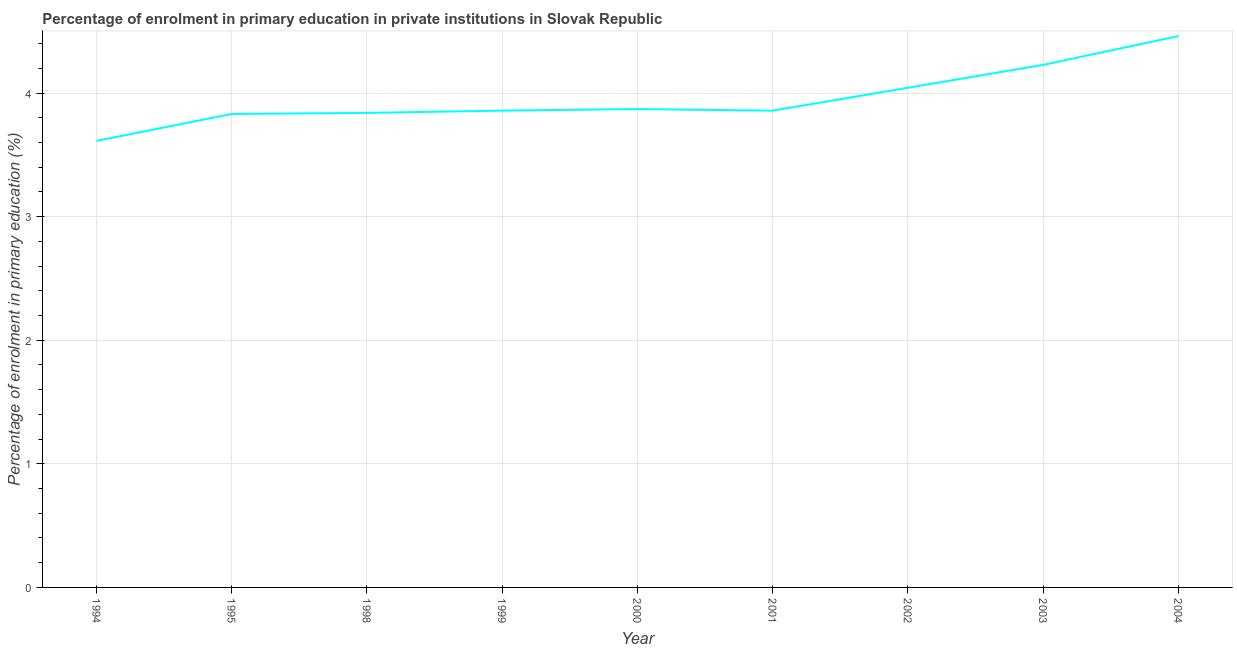What is the enrolment percentage in primary education in 2004?
Your answer should be compact. 4.46. Across all years, what is the maximum enrolment percentage in primary education?
Your response must be concise. 4.46. Across all years, what is the minimum enrolment percentage in primary education?
Keep it short and to the point. 3.61. In which year was the enrolment percentage in primary education maximum?
Provide a short and direct response. 2004. In which year was the enrolment percentage in primary education minimum?
Provide a short and direct response. 1994. What is the sum of the enrolment percentage in primary education?
Offer a very short reply. 35.61. What is the difference between the enrolment percentage in primary education in 1998 and 2004?
Your response must be concise. -0.62. What is the average enrolment percentage in primary education per year?
Provide a succinct answer. 3.96. What is the median enrolment percentage in primary education?
Provide a short and direct response. 3.86. Do a majority of the years between 2001 and 1995 (inclusive) have enrolment percentage in primary education greater than 3.4 %?
Ensure brevity in your answer.  Yes. What is the ratio of the enrolment percentage in primary education in 2001 to that in 2002?
Ensure brevity in your answer.  0.95. What is the difference between the highest and the second highest enrolment percentage in primary education?
Make the answer very short. 0.23. Is the sum of the enrolment percentage in primary education in 1994 and 2002 greater than the maximum enrolment percentage in primary education across all years?
Keep it short and to the point. Yes. What is the difference between the highest and the lowest enrolment percentage in primary education?
Ensure brevity in your answer.  0.85. In how many years, is the enrolment percentage in primary education greater than the average enrolment percentage in primary education taken over all years?
Your response must be concise. 3. Does the enrolment percentage in primary education monotonically increase over the years?
Make the answer very short. No. How many years are there in the graph?
Make the answer very short. 9. Are the values on the major ticks of Y-axis written in scientific E-notation?
Keep it short and to the point. No. Does the graph contain any zero values?
Offer a very short reply. No. What is the title of the graph?
Offer a very short reply. Percentage of enrolment in primary education in private institutions in Slovak Republic. What is the label or title of the X-axis?
Make the answer very short. Year. What is the label or title of the Y-axis?
Offer a very short reply. Percentage of enrolment in primary education (%). What is the Percentage of enrolment in primary education (%) in 1994?
Provide a short and direct response. 3.61. What is the Percentage of enrolment in primary education (%) of 1995?
Your answer should be compact. 3.83. What is the Percentage of enrolment in primary education (%) in 1998?
Provide a succinct answer. 3.84. What is the Percentage of enrolment in primary education (%) of 1999?
Make the answer very short. 3.86. What is the Percentage of enrolment in primary education (%) in 2000?
Your answer should be compact. 3.87. What is the Percentage of enrolment in primary education (%) of 2001?
Keep it short and to the point. 3.86. What is the Percentage of enrolment in primary education (%) of 2002?
Your response must be concise. 4.04. What is the Percentage of enrolment in primary education (%) of 2003?
Your answer should be compact. 4.23. What is the Percentage of enrolment in primary education (%) of 2004?
Make the answer very short. 4.46. What is the difference between the Percentage of enrolment in primary education (%) in 1994 and 1995?
Ensure brevity in your answer.  -0.22. What is the difference between the Percentage of enrolment in primary education (%) in 1994 and 1998?
Your response must be concise. -0.23. What is the difference between the Percentage of enrolment in primary education (%) in 1994 and 1999?
Ensure brevity in your answer.  -0.24. What is the difference between the Percentage of enrolment in primary education (%) in 1994 and 2000?
Your answer should be compact. -0.26. What is the difference between the Percentage of enrolment in primary education (%) in 1994 and 2001?
Provide a short and direct response. -0.24. What is the difference between the Percentage of enrolment in primary education (%) in 1994 and 2002?
Give a very brief answer. -0.43. What is the difference between the Percentage of enrolment in primary education (%) in 1994 and 2003?
Offer a very short reply. -0.61. What is the difference between the Percentage of enrolment in primary education (%) in 1994 and 2004?
Offer a terse response. -0.85. What is the difference between the Percentage of enrolment in primary education (%) in 1995 and 1998?
Ensure brevity in your answer.  -0.01. What is the difference between the Percentage of enrolment in primary education (%) in 1995 and 1999?
Your answer should be very brief. -0.03. What is the difference between the Percentage of enrolment in primary education (%) in 1995 and 2000?
Offer a very short reply. -0.04. What is the difference between the Percentage of enrolment in primary education (%) in 1995 and 2001?
Provide a succinct answer. -0.03. What is the difference between the Percentage of enrolment in primary education (%) in 1995 and 2002?
Keep it short and to the point. -0.21. What is the difference between the Percentage of enrolment in primary education (%) in 1995 and 2003?
Your response must be concise. -0.4. What is the difference between the Percentage of enrolment in primary education (%) in 1995 and 2004?
Offer a very short reply. -0.63. What is the difference between the Percentage of enrolment in primary education (%) in 1998 and 1999?
Your answer should be very brief. -0.02. What is the difference between the Percentage of enrolment in primary education (%) in 1998 and 2000?
Offer a very short reply. -0.03. What is the difference between the Percentage of enrolment in primary education (%) in 1998 and 2001?
Your response must be concise. -0.02. What is the difference between the Percentage of enrolment in primary education (%) in 1998 and 2002?
Offer a terse response. -0.2. What is the difference between the Percentage of enrolment in primary education (%) in 1998 and 2003?
Ensure brevity in your answer.  -0.39. What is the difference between the Percentage of enrolment in primary education (%) in 1998 and 2004?
Keep it short and to the point. -0.62. What is the difference between the Percentage of enrolment in primary education (%) in 1999 and 2000?
Your answer should be very brief. -0.01. What is the difference between the Percentage of enrolment in primary education (%) in 1999 and 2001?
Offer a very short reply. 0. What is the difference between the Percentage of enrolment in primary education (%) in 1999 and 2002?
Provide a short and direct response. -0.18. What is the difference between the Percentage of enrolment in primary education (%) in 1999 and 2003?
Make the answer very short. -0.37. What is the difference between the Percentage of enrolment in primary education (%) in 1999 and 2004?
Offer a very short reply. -0.6. What is the difference between the Percentage of enrolment in primary education (%) in 2000 and 2001?
Offer a very short reply. 0.01. What is the difference between the Percentage of enrolment in primary education (%) in 2000 and 2002?
Offer a terse response. -0.17. What is the difference between the Percentage of enrolment in primary education (%) in 2000 and 2003?
Make the answer very short. -0.36. What is the difference between the Percentage of enrolment in primary education (%) in 2000 and 2004?
Provide a short and direct response. -0.59. What is the difference between the Percentage of enrolment in primary education (%) in 2001 and 2002?
Ensure brevity in your answer.  -0.19. What is the difference between the Percentage of enrolment in primary education (%) in 2001 and 2003?
Ensure brevity in your answer.  -0.37. What is the difference between the Percentage of enrolment in primary education (%) in 2001 and 2004?
Your answer should be very brief. -0.6. What is the difference between the Percentage of enrolment in primary education (%) in 2002 and 2003?
Your answer should be compact. -0.19. What is the difference between the Percentage of enrolment in primary education (%) in 2002 and 2004?
Provide a short and direct response. -0.42. What is the difference between the Percentage of enrolment in primary education (%) in 2003 and 2004?
Provide a succinct answer. -0.23. What is the ratio of the Percentage of enrolment in primary education (%) in 1994 to that in 1995?
Your answer should be compact. 0.94. What is the ratio of the Percentage of enrolment in primary education (%) in 1994 to that in 1998?
Provide a succinct answer. 0.94. What is the ratio of the Percentage of enrolment in primary education (%) in 1994 to that in 1999?
Offer a terse response. 0.94. What is the ratio of the Percentage of enrolment in primary education (%) in 1994 to that in 2000?
Ensure brevity in your answer.  0.93. What is the ratio of the Percentage of enrolment in primary education (%) in 1994 to that in 2001?
Your answer should be very brief. 0.94. What is the ratio of the Percentage of enrolment in primary education (%) in 1994 to that in 2002?
Provide a short and direct response. 0.89. What is the ratio of the Percentage of enrolment in primary education (%) in 1994 to that in 2003?
Your answer should be compact. 0.85. What is the ratio of the Percentage of enrolment in primary education (%) in 1994 to that in 2004?
Ensure brevity in your answer.  0.81. What is the ratio of the Percentage of enrolment in primary education (%) in 1995 to that in 1998?
Give a very brief answer. 1. What is the ratio of the Percentage of enrolment in primary education (%) in 1995 to that in 2000?
Provide a short and direct response. 0.99. What is the ratio of the Percentage of enrolment in primary education (%) in 1995 to that in 2001?
Your answer should be compact. 0.99. What is the ratio of the Percentage of enrolment in primary education (%) in 1995 to that in 2002?
Keep it short and to the point. 0.95. What is the ratio of the Percentage of enrolment in primary education (%) in 1995 to that in 2003?
Your response must be concise. 0.91. What is the ratio of the Percentage of enrolment in primary education (%) in 1995 to that in 2004?
Give a very brief answer. 0.86. What is the ratio of the Percentage of enrolment in primary education (%) in 1998 to that in 1999?
Keep it short and to the point. 0.99. What is the ratio of the Percentage of enrolment in primary education (%) in 1998 to that in 2000?
Keep it short and to the point. 0.99. What is the ratio of the Percentage of enrolment in primary education (%) in 1998 to that in 2001?
Your answer should be compact. 0.99. What is the ratio of the Percentage of enrolment in primary education (%) in 1998 to that in 2002?
Ensure brevity in your answer.  0.95. What is the ratio of the Percentage of enrolment in primary education (%) in 1998 to that in 2003?
Provide a succinct answer. 0.91. What is the ratio of the Percentage of enrolment in primary education (%) in 1998 to that in 2004?
Ensure brevity in your answer.  0.86. What is the ratio of the Percentage of enrolment in primary education (%) in 1999 to that in 2002?
Keep it short and to the point. 0.95. What is the ratio of the Percentage of enrolment in primary education (%) in 1999 to that in 2003?
Provide a short and direct response. 0.91. What is the ratio of the Percentage of enrolment in primary education (%) in 1999 to that in 2004?
Give a very brief answer. 0.86. What is the ratio of the Percentage of enrolment in primary education (%) in 2000 to that in 2001?
Your response must be concise. 1. What is the ratio of the Percentage of enrolment in primary education (%) in 2000 to that in 2002?
Your answer should be very brief. 0.96. What is the ratio of the Percentage of enrolment in primary education (%) in 2000 to that in 2003?
Your response must be concise. 0.92. What is the ratio of the Percentage of enrolment in primary education (%) in 2000 to that in 2004?
Ensure brevity in your answer.  0.87. What is the ratio of the Percentage of enrolment in primary education (%) in 2001 to that in 2002?
Your response must be concise. 0.95. What is the ratio of the Percentage of enrolment in primary education (%) in 2001 to that in 2003?
Ensure brevity in your answer.  0.91. What is the ratio of the Percentage of enrolment in primary education (%) in 2001 to that in 2004?
Ensure brevity in your answer.  0.86. What is the ratio of the Percentage of enrolment in primary education (%) in 2002 to that in 2003?
Make the answer very short. 0.96. What is the ratio of the Percentage of enrolment in primary education (%) in 2002 to that in 2004?
Offer a terse response. 0.91. What is the ratio of the Percentage of enrolment in primary education (%) in 2003 to that in 2004?
Keep it short and to the point. 0.95. 